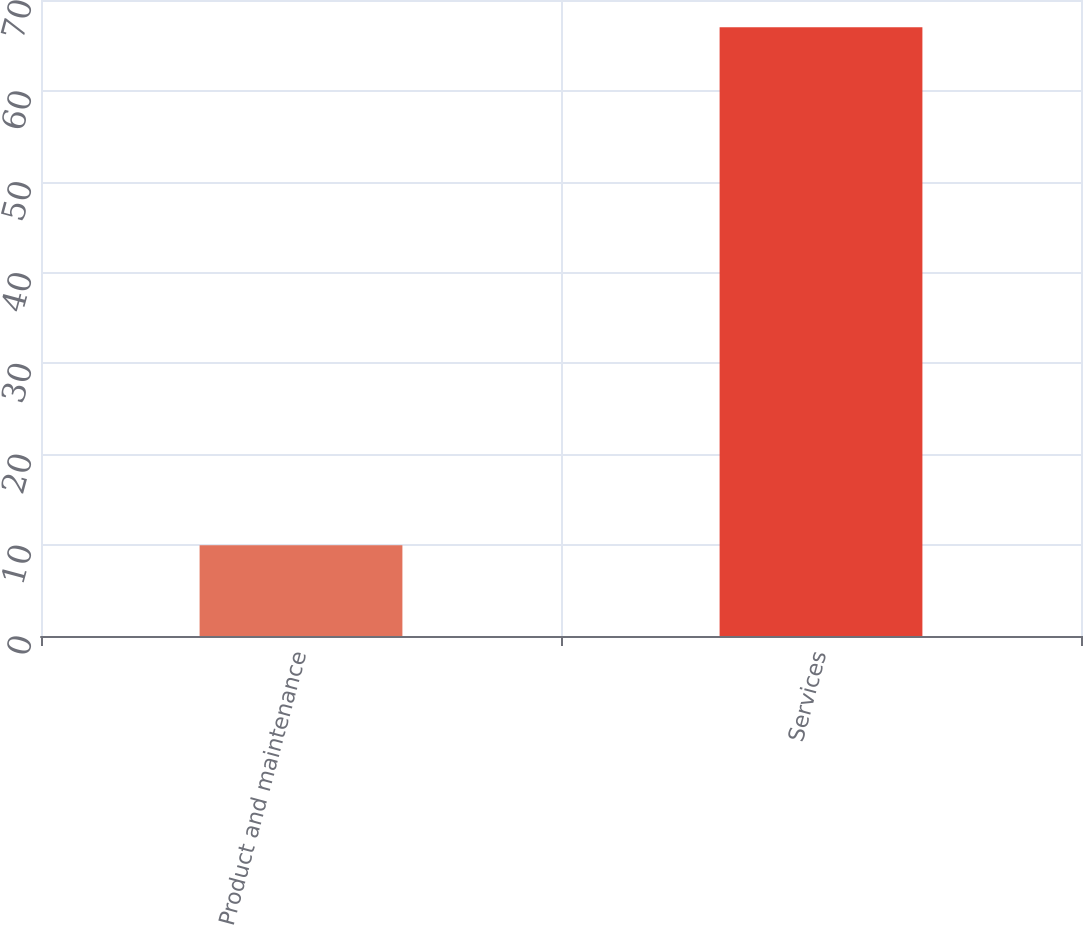<chart> <loc_0><loc_0><loc_500><loc_500><bar_chart><fcel>Product and maintenance<fcel>Services<nl><fcel>10<fcel>67<nl></chart> 